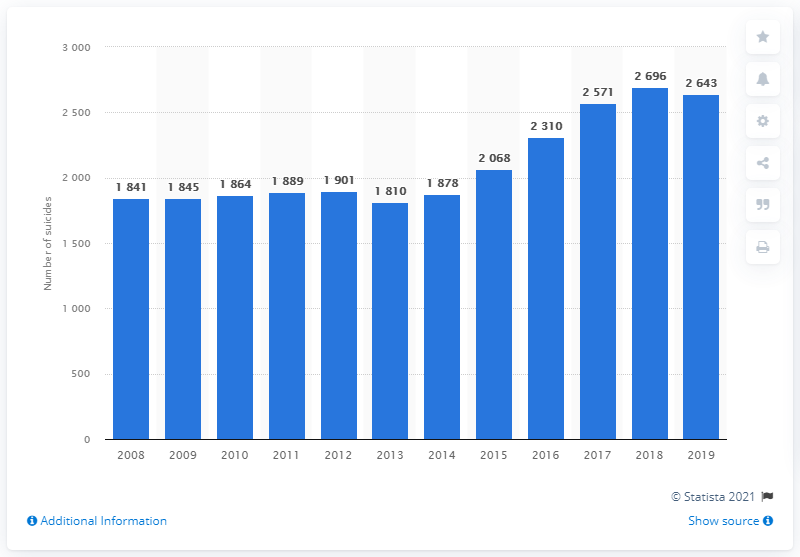Specify some key components in this picture. In 2019, the number of suicides in Colombia decreased. 